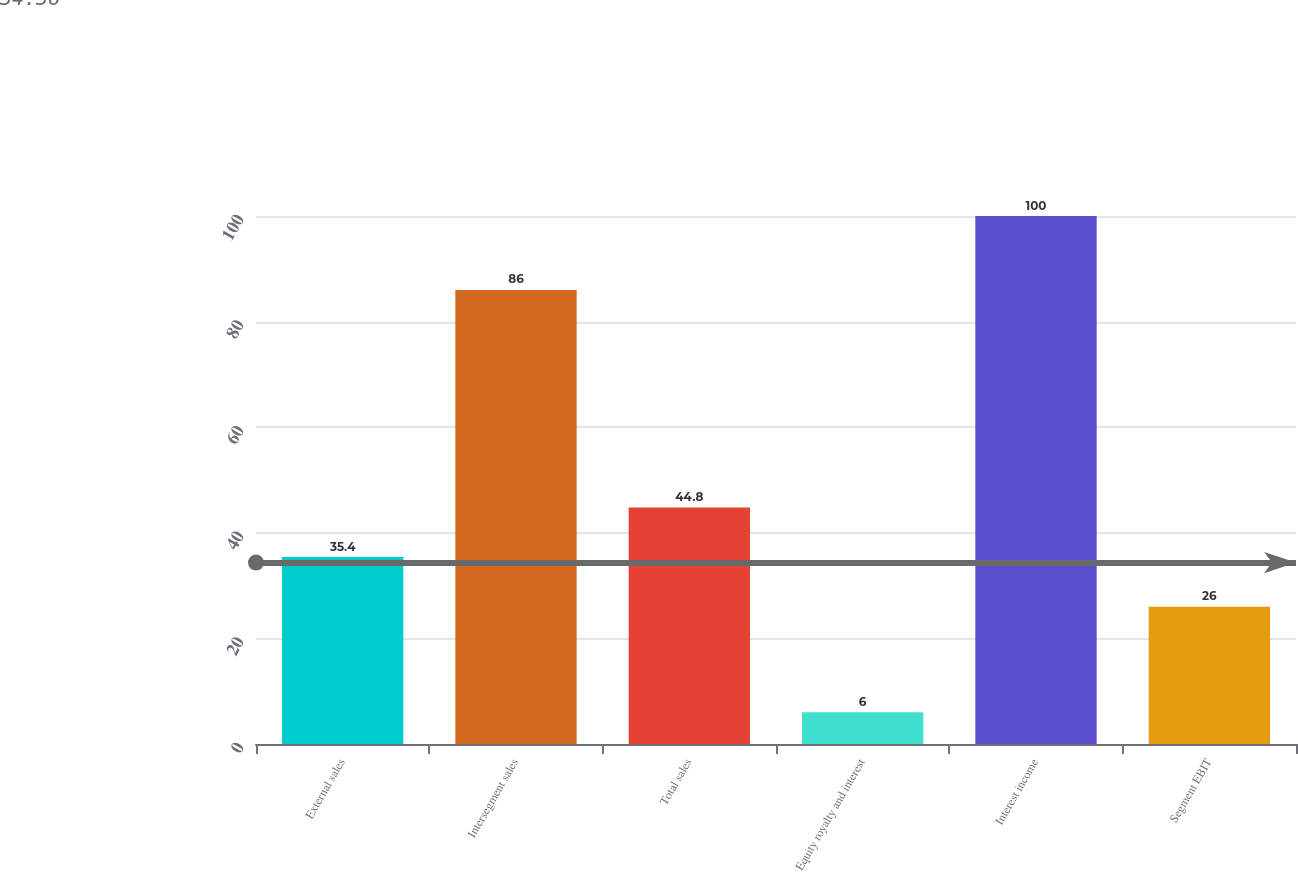Convert chart to OTSL. <chart><loc_0><loc_0><loc_500><loc_500><bar_chart><fcel>External sales<fcel>Intersegment sales<fcel>Total sales<fcel>Equity royalty and interest<fcel>Interest income<fcel>Segment EBIT<nl><fcel>35.4<fcel>86<fcel>44.8<fcel>6<fcel>100<fcel>26<nl></chart> 